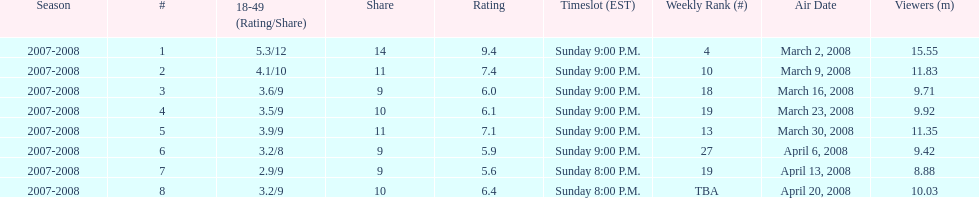Can you parse all the data within this table? {'header': ['Season', '#', '18-49 (Rating/Share)', 'Share', 'Rating', 'Timeslot (EST)', 'Weekly Rank (#)', 'Air Date', 'Viewers (m)'], 'rows': [['2007-2008', '1', '5.3/12', '14', '9.4', 'Sunday 9:00 P.M.', '4', 'March 2, 2008', '15.55'], ['2007-2008', '2', '4.1/10', '11', '7.4', 'Sunday 9:00 P.M.', '10', 'March 9, 2008', '11.83'], ['2007-2008', '3', '3.6/9', '9', '6.0', 'Sunday 9:00 P.M.', '18', 'March 16, 2008', '9.71'], ['2007-2008', '4', '3.5/9', '10', '6.1', 'Sunday 9:00 P.M.', '19', 'March 23, 2008', '9.92'], ['2007-2008', '5', '3.9/9', '11', '7.1', 'Sunday 9:00 P.M.', '13', 'March 30, 2008', '11.35'], ['2007-2008', '6', '3.2/8', '9', '5.9', 'Sunday 9:00 P.M.', '27', 'April 6, 2008', '9.42'], ['2007-2008', '7', '2.9/9', '9', '5.6', 'Sunday 8:00 P.M.', '19', 'April 13, 2008', '8.88'], ['2007-2008', '8', '3.2/9', '10', '6.4', 'Sunday 8:00 P.M.', 'TBA', 'April 20, 2008', '10.03']]} What episode had the highest rating? March 2, 2008. 